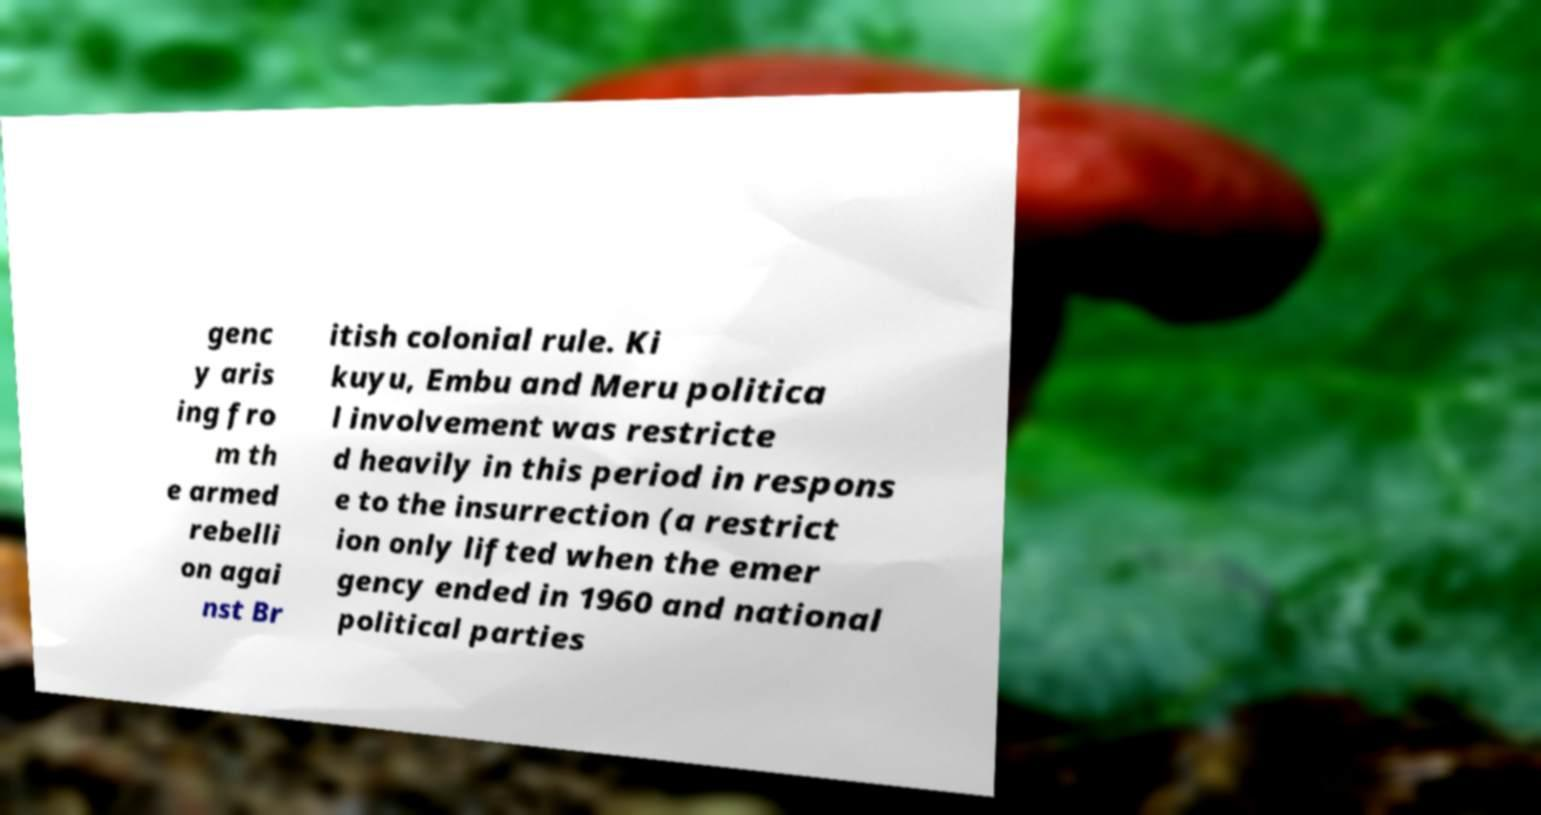Please read and relay the text visible in this image. What does it say? genc y aris ing fro m th e armed rebelli on agai nst Br itish colonial rule. Ki kuyu, Embu and Meru politica l involvement was restricte d heavily in this period in respons e to the insurrection (a restrict ion only lifted when the emer gency ended in 1960 and national political parties 